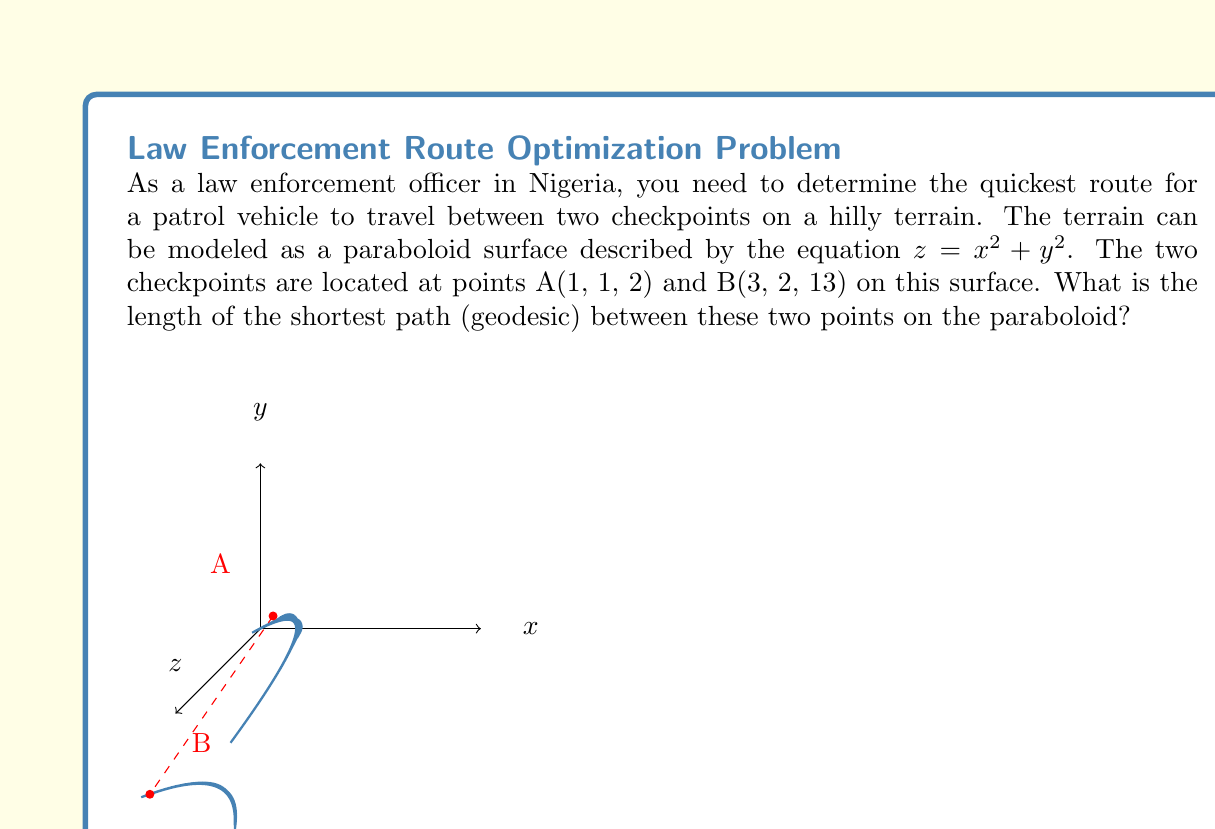What is the answer to this math problem? To solve this problem, we need to follow these steps:

1) The shortest path between two points on a curved surface is called a geodesic. For a paraboloid, there's no simple formula to calculate the geodesic directly.

2) We can approximate the geodesic length using the following steps:

   a) Find the straight-line distance between the points in 3D space.
   b) Calculate the surface distance along the paraboloid.
   c) The geodesic length will be between these two values, typically closer to the straight-line distance.

3) Let's calculate the straight-line distance:
   
   $$d = \sqrt{(x_2-x_1)^2 + (y_2-y_1)^2 + (z_2-z_1)^2}$$
   $$d = \sqrt{(3-1)^2 + (2-1)^2 + (13-2)^2}$$
   $$d = \sqrt{4 + 1 + 121} = \sqrt{126} \approx 11.22$$

4) Now, let's calculate the surface distance. We can do this by parameterizing the path:

   $$x(t) = 1 + 2t$$
   $$y(t) = 1 + t$$
   $$z(t) = x(t)^2 + y(t)^2 = (1+2t)^2 + (1+t)^2$$

   The surface distance is given by the integral:

   $$L = \int_0^1 \sqrt{(\frac{dx}{dt})^2 + (\frac{dy}{dt})^2 + (\frac{dz}{dt})^2} dt$$

5) Calculating the derivatives:

   $$\frac{dx}{dt} = 2$$
   $$\frac{dy}{dt} = 1$$
   $$\frac{dz}{dt} = 4(1+2t) + 2(1+t) = 4 + 8t + 2 + 2t = 6 + 10t$$

6) Substituting into the integral:

   $$L = \int_0^1 \sqrt{4 + 1 + (6+10t)^2} dt$$

7) This integral is complex and doesn't have a simple analytical solution. We would need to use numerical integration methods to solve it precisely.

8) The actual geodesic length will be between the straight-line distance (11.22) and this surface distance.

9) For practical purposes in this scenario, the straight-line distance (11.22) can be used as a good approximation of the geodesic length.
Answer: Approximately 11.22 units 